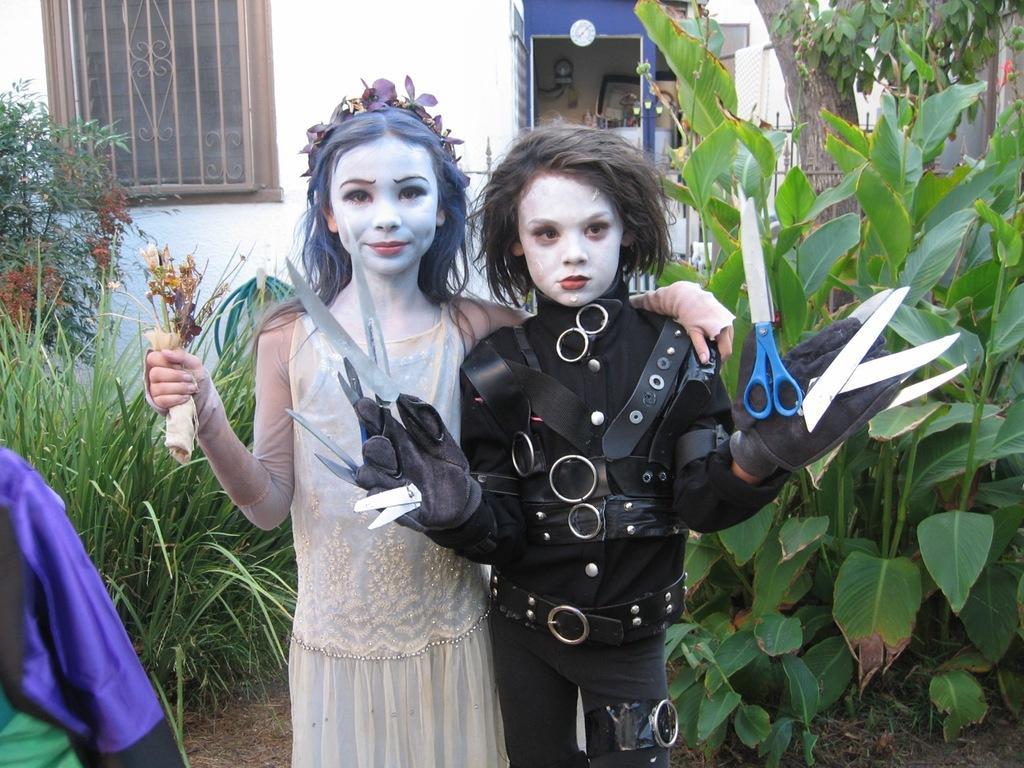Can you describe this image briefly? In this image I can see two person standing. They are wearing white and black dress and holding something. Back I can see building,trees and windows. The wall is in white color. 